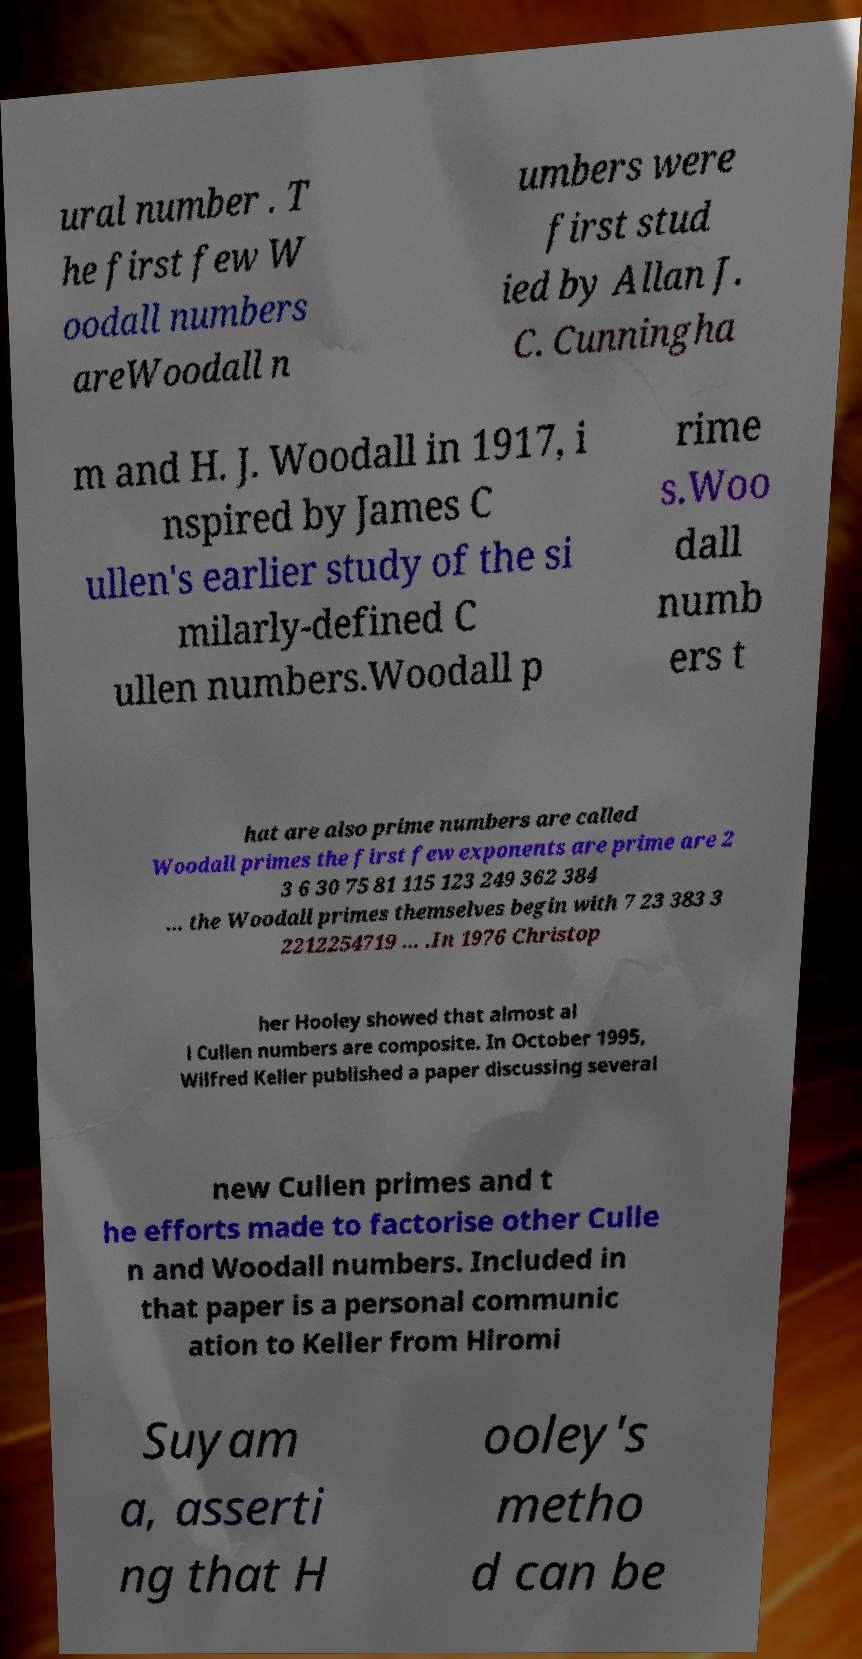Could you assist in decoding the text presented in this image and type it out clearly? ural number . T he first few W oodall numbers areWoodall n umbers were first stud ied by Allan J. C. Cunningha m and H. J. Woodall in 1917, i nspired by James C ullen's earlier study of the si milarly-defined C ullen numbers.Woodall p rime s.Woo dall numb ers t hat are also prime numbers are called Woodall primes the first few exponents are prime are 2 3 6 30 75 81 115 123 249 362 384 … the Woodall primes themselves begin with 7 23 383 3 2212254719 … .In 1976 Christop her Hooley showed that almost al l Cullen numbers are composite. In October 1995, Wilfred Keller published a paper discussing several new Cullen primes and t he efforts made to factorise other Culle n and Woodall numbers. Included in that paper is a personal communic ation to Keller from Hiromi Suyam a, asserti ng that H ooley's metho d can be 